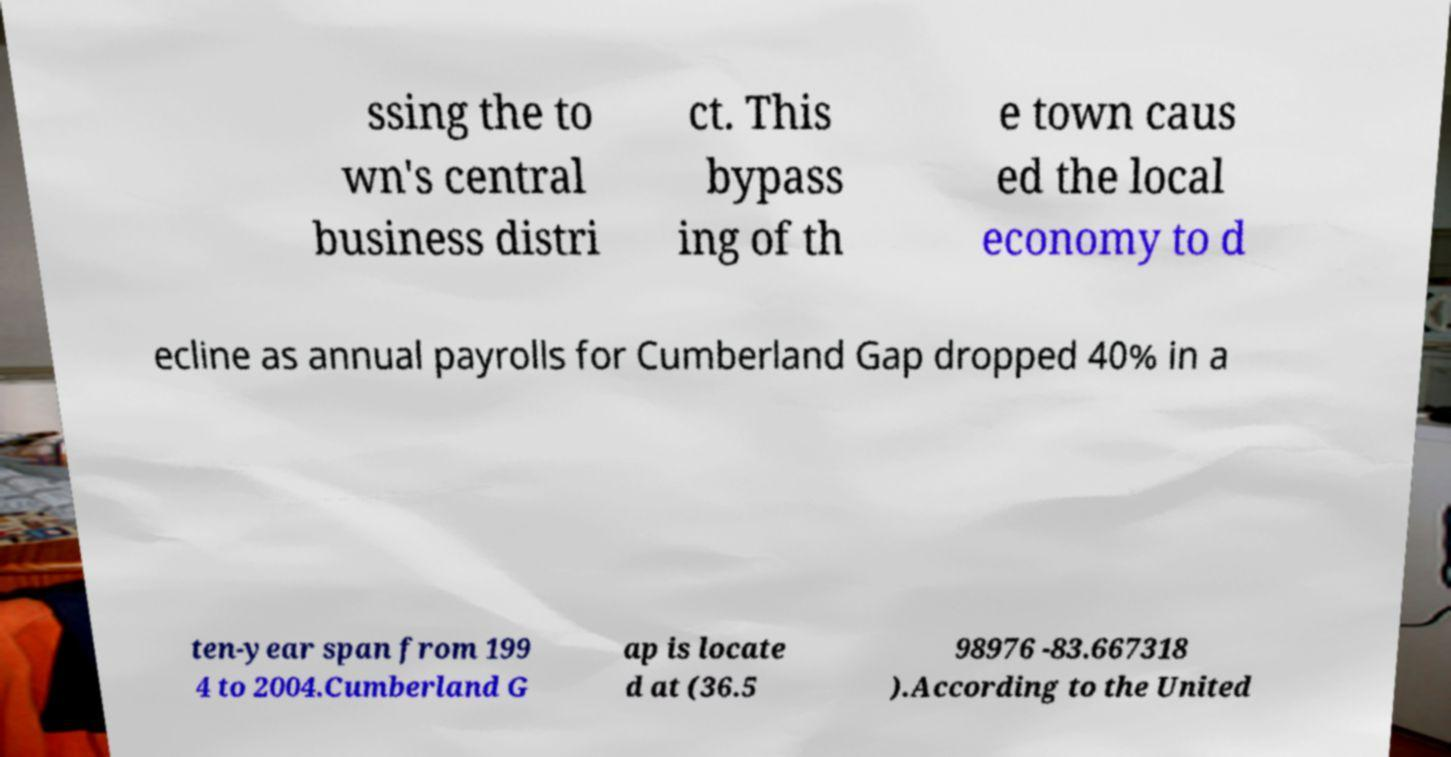There's text embedded in this image that I need extracted. Can you transcribe it verbatim? ssing the to wn's central business distri ct. This bypass ing of th e town caus ed the local economy to d ecline as annual payrolls for Cumberland Gap dropped 40% in a ten-year span from 199 4 to 2004.Cumberland G ap is locate d at (36.5 98976 -83.667318 ).According to the United 